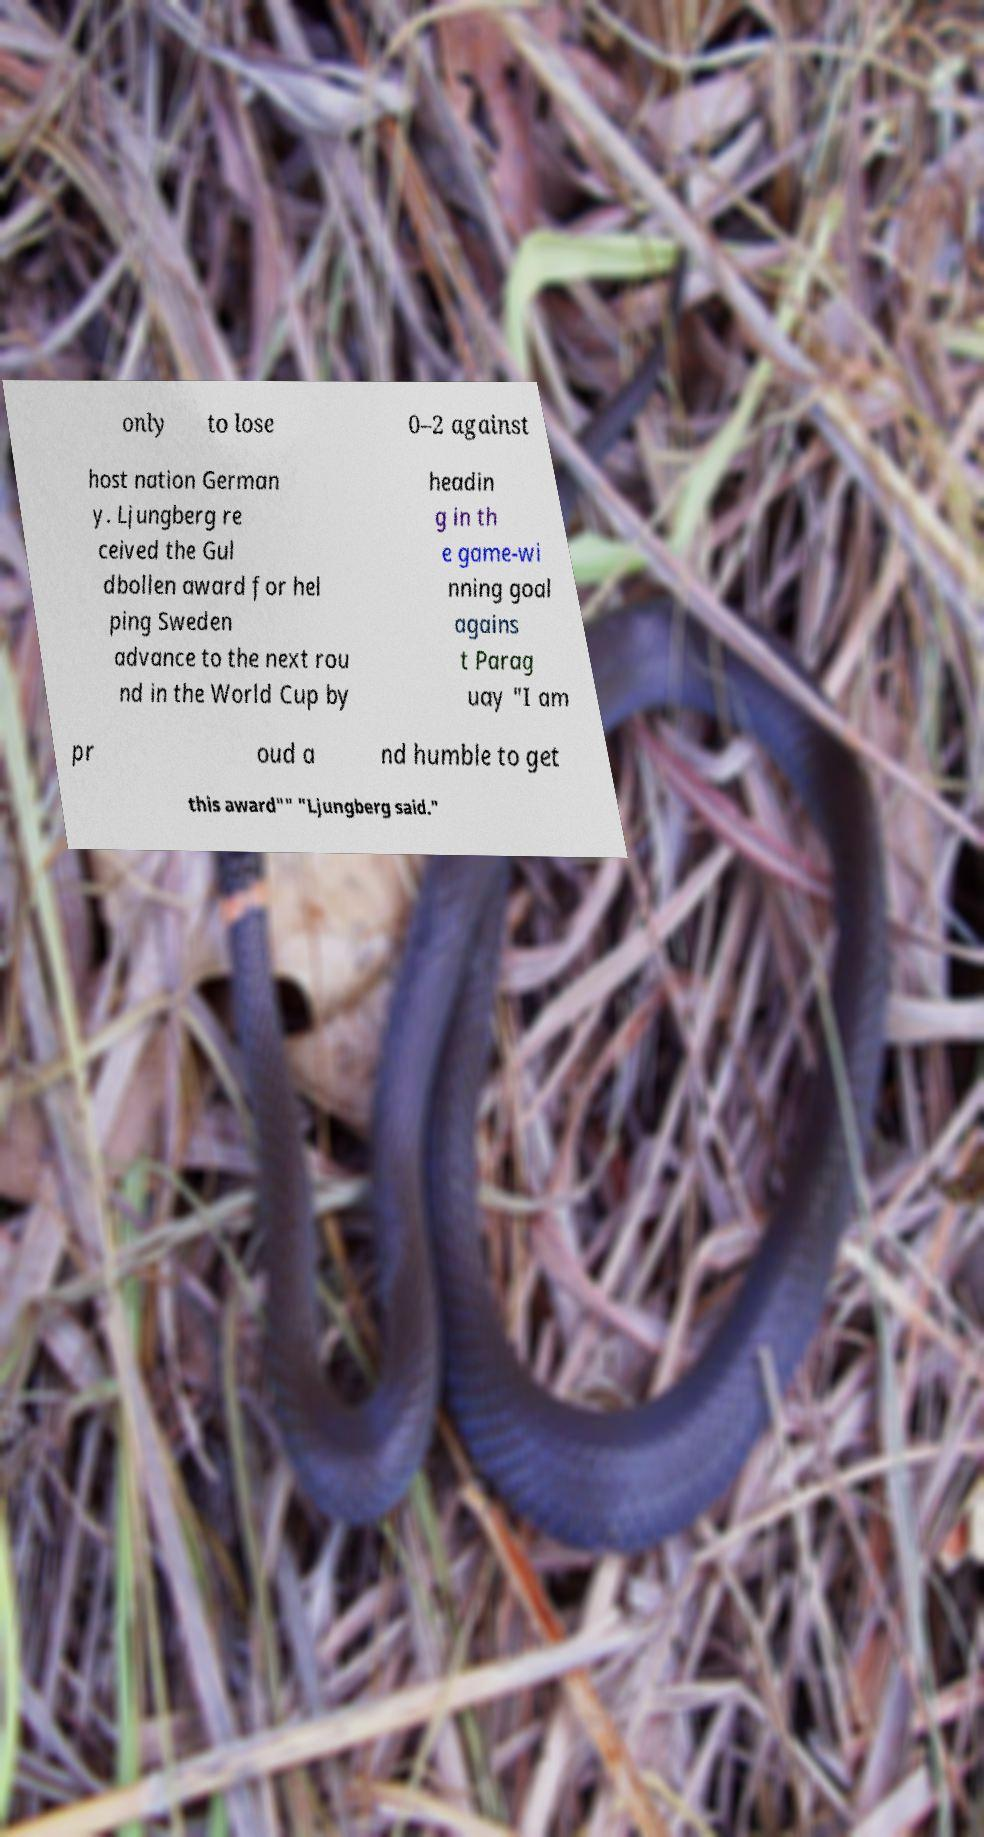Can you read and provide the text displayed in the image?This photo seems to have some interesting text. Can you extract and type it out for me? only to lose 0–2 against host nation German y. Ljungberg re ceived the Gul dbollen award for hel ping Sweden advance to the next rou nd in the World Cup by headin g in th e game-wi nning goal agains t Parag uay "I am pr oud a nd humble to get this award"" "Ljungberg said." 